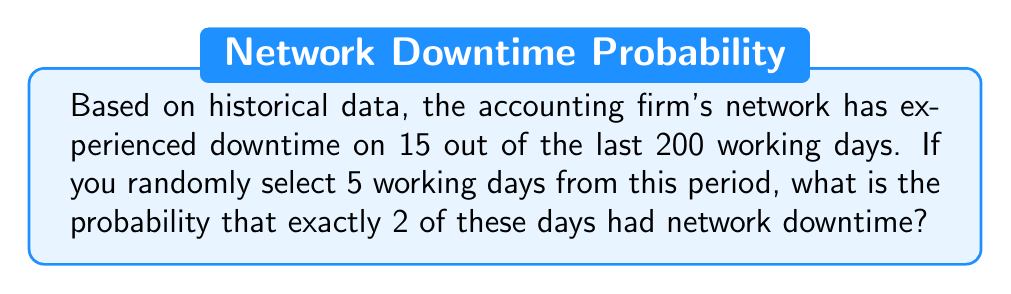Can you answer this question? Let's approach this step-by-step:

1) First, we need to calculate the probability of a single day having network downtime:
   $p = \frac{15}{200} = 0.075$ or 7.5%

2) The probability of a day not having downtime is:
   $q = 1 - p = 1 - 0.075 = 0.925$ or 92.5%

3) This scenario follows a binomial distribution with:
   $n = 5$ (number of days selected)
   $k = 2$ (number of days with downtime we're interested in)
   $p = 0.075$ (probability of downtime on a single day)

4) The probability mass function for a binomial distribution is:

   $$P(X = k) = \binom{n}{k} p^k (1-p)^{n-k}$$

5) Substituting our values:

   $$P(X = 2) = \binom{5}{2} (0.075)^2 (0.925)^{5-2}$$

6) Calculate the binomial coefficient:
   $$\binom{5}{2} = \frac{5!}{2!(5-2)!} = \frac{5 * 4}{2 * 1} = 10$$

7) Now we can compute:

   $$P(X = 2) = 10 * (0.075)^2 * (0.925)^3$$
   $$= 10 * 0.005625 * 0.790123$$
   $$= 0.0444444375$$

8) Therefore, the probability is approximately 0.0444 or 4.44%
Answer: 0.0444 